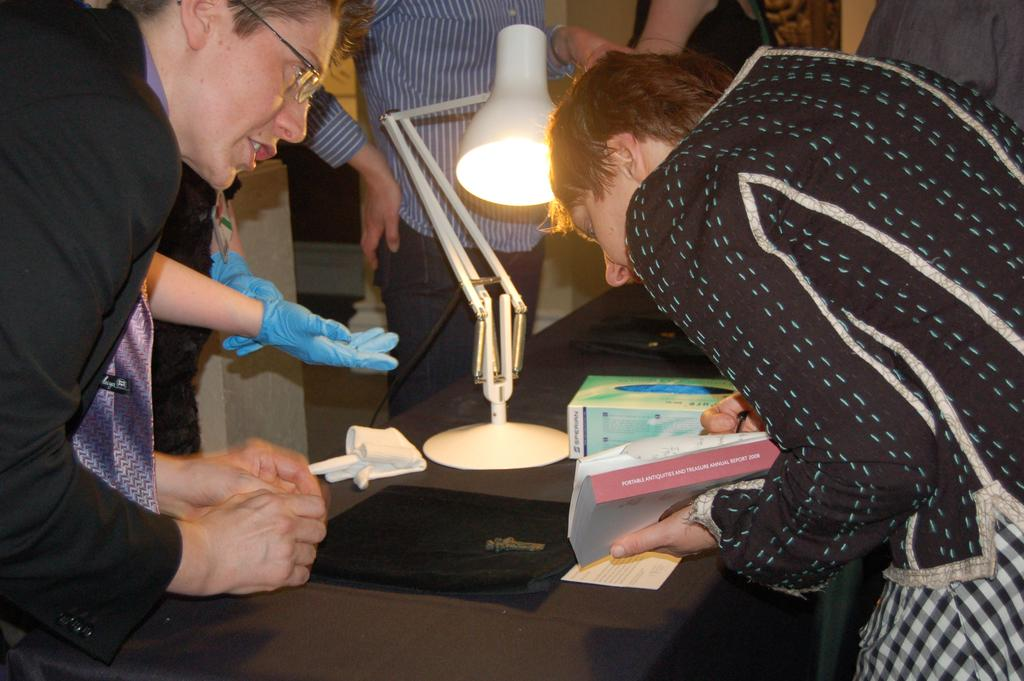What is happening in the image involving people? There are people standing around a table in the image. What object is on the table with the people? There is a lamp on the table. Are there any other light sources in the image? Yes, there is a chandelier present in the image. How many ants are crawling on the lamp in the image? There are no ants present in the image, so it is not possible to determine how many would be crawling on the lamp. 